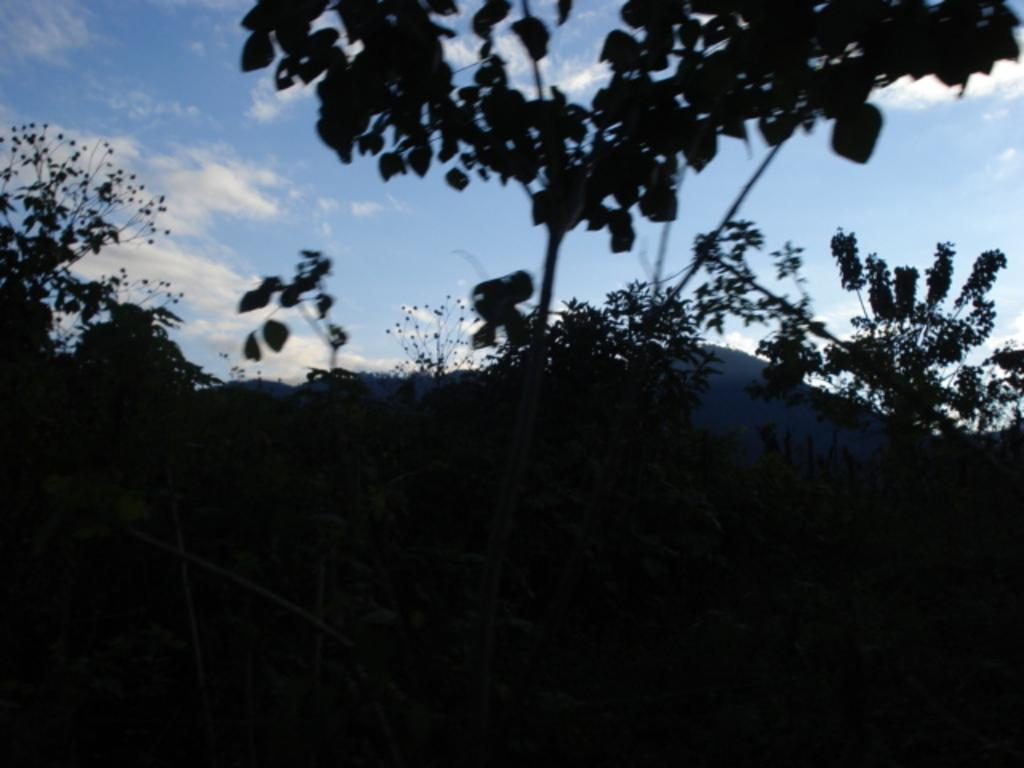What type of living organisms can be seen in the image? Plants can be seen in the image. What part of the natural environment is visible in the image? The sky is visible in the image. Can you describe the color of the sky in the image? The sky has a white and blue color in the image. How would you describe the lighting in the image? The image appears to be dark. What type of secretary can be seen in the image? There is no secretary present in the image. What sound do the bells make in the image? There are no bells present in the image. 